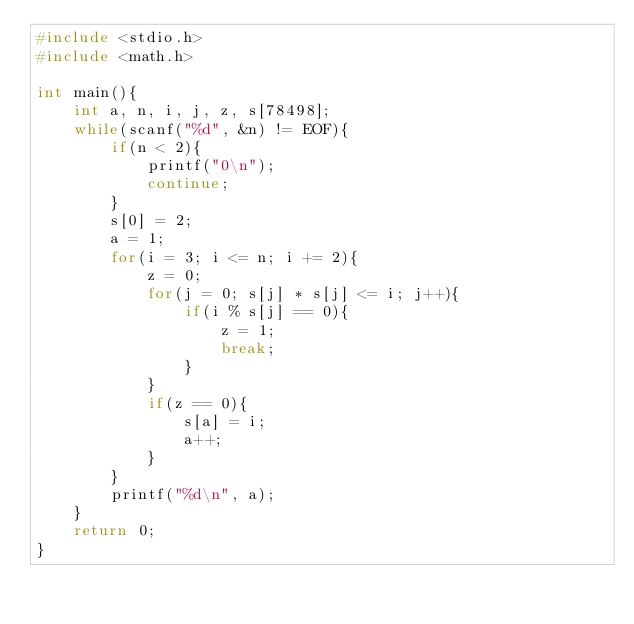<code> <loc_0><loc_0><loc_500><loc_500><_C_>#include <stdio.h>
#include <math.h>

int main(){
	int a, n, i, j, z, s[78498];
	while(scanf("%d", &n) != EOF){
		if(n < 2){
			printf("0\n");
			continue;
		}
		s[0] = 2;
		a = 1;
		for(i = 3; i <= n; i += 2){
			z = 0;
			for(j = 0; s[j] * s[j] <= i; j++){
				if(i % s[j] == 0){
					z = 1;
					break;
				}
			}
			if(z == 0){
				s[a] = i;
				a++;
			}
		}
		printf("%d\n", a);
	}
	return 0;
}</code> 